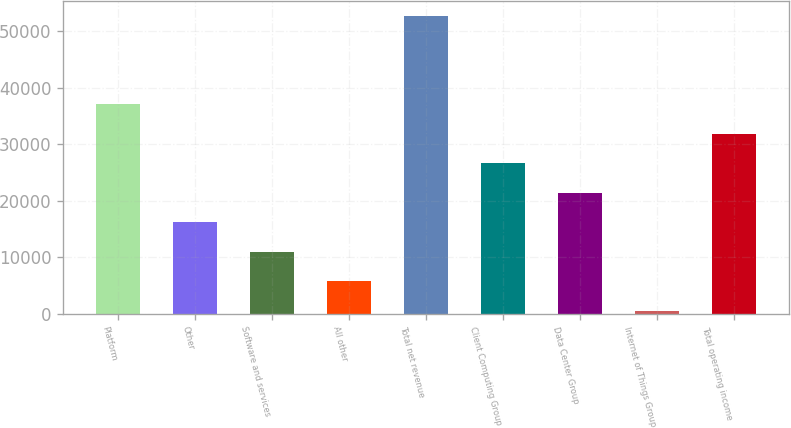Convert chart to OTSL. <chart><loc_0><loc_0><loc_500><loc_500><bar_chart><fcel>Platform<fcel>Other<fcel>Software and services<fcel>All other<fcel>Total net revenue<fcel>Client Computing Group<fcel>Data Center Group<fcel>Internet of Things Group<fcel>Total operating income<nl><fcel>37055.2<fcel>16184.8<fcel>10967.2<fcel>5749.6<fcel>52708<fcel>26620<fcel>21402.4<fcel>532<fcel>31837.6<nl></chart> 